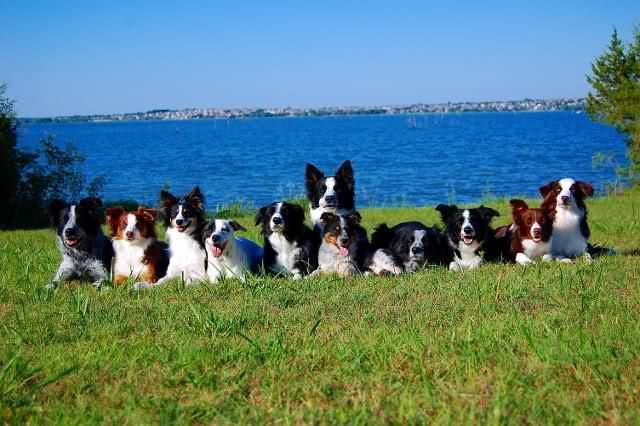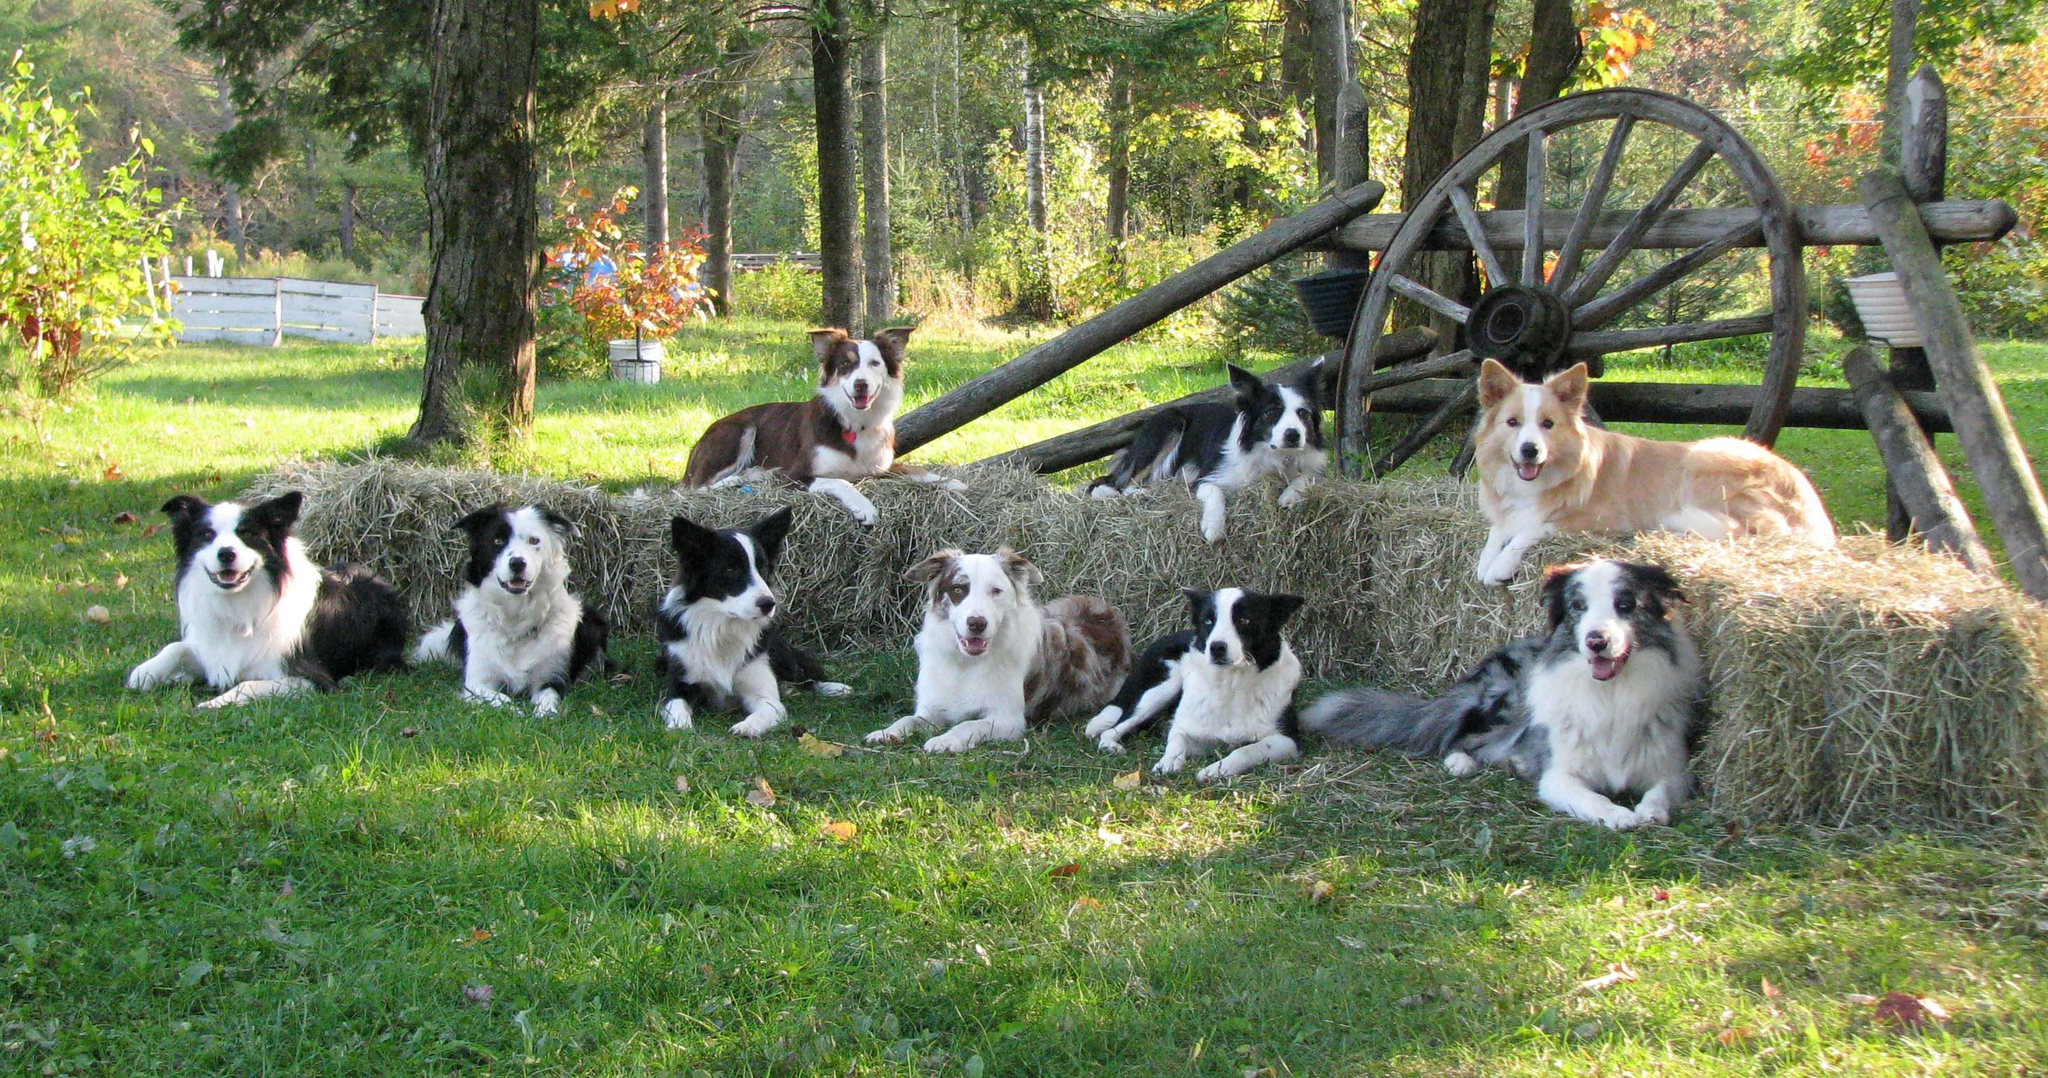The first image is the image on the left, the second image is the image on the right. Considering the images on both sides, is "There are at least three dogs with white fur elevated above another row of dogs who are sitting or laying down." valid? Answer yes or no. Yes. 